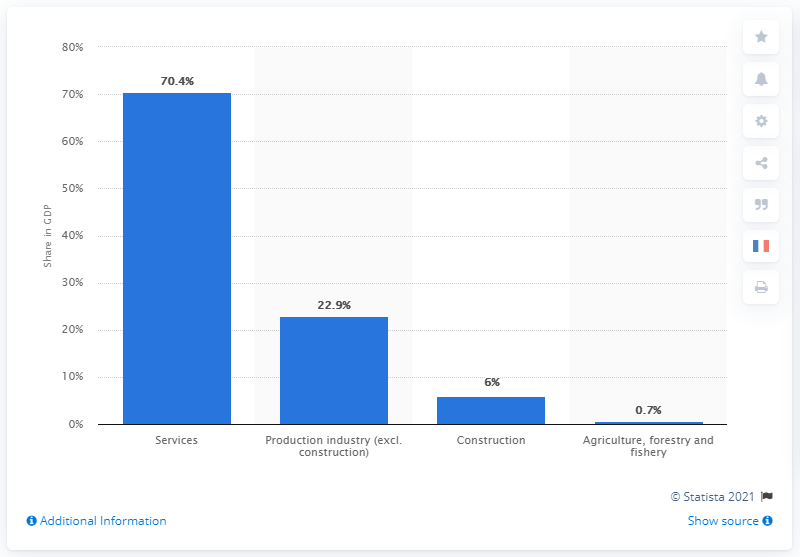Indicate a few pertinent items in this graphic. In 2020, the service sector accounted for 70.4% of Germany's gross domestic product. 